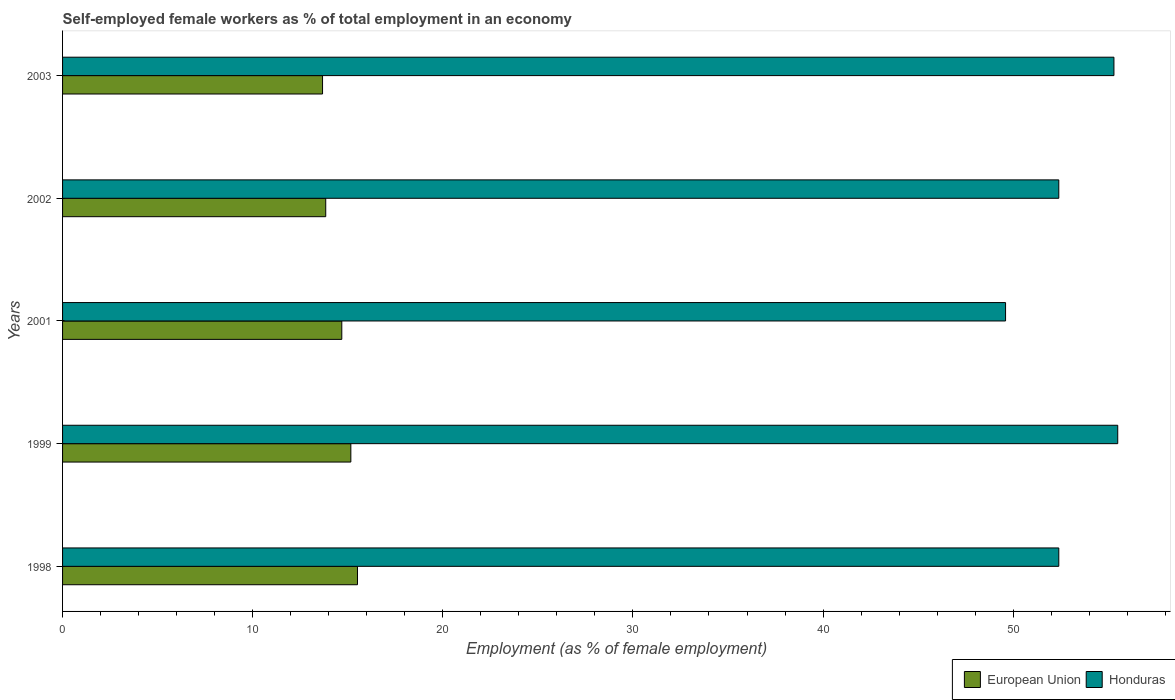Are the number of bars per tick equal to the number of legend labels?
Provide a succinct answer. Yes. How many bars are there on the 5th tick from the top?
Provide a succinct answer. 2. How many bars are there on the 5th tick from the bottom?
Your answer should be very brief. 2. In how many cases, is the number of bars for a given year not equal to the number of legend labels?
Your answer should be compact. 0. What is the percentage of self-employed female workers in Honduras in 2002?
Keep it short and to the point. 52.4. Across all years, what is the maximum percentage of self-employed female workers in Honduras?
Offer a very short reply. 55.5. Across all years, what is the minimum percentage of self-employed female workers in Honduras?
Ensure brevity in your answer.  49.6. What is the total percentage of self-employed female workers in Honduras in the graph?
Your answer should be very brief. 265.2. What is the difference between the percentage of self-employed female workers in European Union in 1998 and that in 1999?
Offer a terse response. 0.35. What is the difference between the percentage of self-employed female workers in European Union in 2001 and the percentage of self-employed female workers in Honduras in 2003?
Give a very brief answer. -40.61. What is the average percentage of self-employed female workers in European Union per year?
Offer a terse response. 14.58. In the year 2002, what is the difference between the percentage of self-employed female workers in European Union and percentage of self-employed female workers in Honduras?
Offer a very short reply. -38.56. What is the ratio of the percentage of self-employed female workers in Honduras in 2002 to that in 2003?
Give a very brief answer. 0.95. Is the difference between the percentage of self-employed female workers in European Union in 1998 and 2003 greater than the difference between the percentage of self-employed female workers in Honduras in 1998 and 2003?
Keep it short and to the point. Yes. What is the difference between the highest and the second highest percentage of self-employed female workers in Honduras?
Provide a short and direct response. 0.2. What is the difference between the highest and the lowest percentage of self-employed female workers in European Union?
Offer a terse response. 1.84. Is the sum of the percentage of self-employed female workers in European Union in 2001 and 2002 greater than the maximum percentage of self-employed female workers in Honduras across all years?
Your response must be concise. No. How many bars are there?
Your answer should be compact. 10. Are all the bars in the graph horizontal?
Ensure brevity in your answer.  Yes. How many years are there in the graph?
Your response must be concise. 5. What is the difference between two consecutive major ticks on the X-axis?
Your answer should be very brief. 10. Are the values on the major ticks of X-axis written in scientific E-notation?
Give a very brief answer. No. Does the graph contain any zero values?
Provide a short and direct response. No. Does the graph contain grids?
Make the answer very short. No. Where does the legend appear in the graph?
Provide a succinct answer. Bottom right. How many legend labels are there?
Provide a succinct answer. 2. What is the title of the graph?
Your answer should be very brief. Self-employed female workers as % of total employment in an economy. Does "Macedonia" appear as one of the legend labels in the graph?
Your response must be concise. No. What is the label or title of the X-axis?
Your response must be concise. Employment (as % of female employment). What is the Employment (as % of female employment) of European Union in 1998?
Provide a succinct answer. 15.51. What is the Employment (as % of female employment) of Honduras in 1998?
Your answer should be compact. 52.4. What is the Employment (as % of female employment) of European Union in 1999?
Provide a short and direct response. 15.16. What is the Employment (as % of female employment) of Honduras in 1999?
Offer a terse response. 55.5. What is the Employment (as % of female employment) in European Union in 2001?
Keep it short and to the point. 14.69. What is the Employment (as % of female employment) in Honduras in 2001?
Keep it short and to the point. 49.6. What is the Employment (as % of female employment) in European Union in 2002?
Make the answer very short. 13.84. What is the Employment (as % of female employment) in Honduras in 2002?
Give a very brief answer. 52.4. What is the Employment (as % of female employment) in European Union in 2003?
Offer a terse response. 13.67. What is the Employment (as % of female employment) in Honduras in 2003?
Give a very brief answer. 55.3. Across all years, what is the maximum Employment (as % of female employment) in European Union?
Make the answer very short. 15.51. Across all years, what is the maximum Employment (as % of female employment) in Honduras?
Offer a very short reply. 55.5. Across all years, what is the minimum Employment (as % of female employment) in European Union?
Keep it short and to the point. 13.67. Across all years, what is the minimum Employment (as % of female employment) of Honduras?
Your response must be concise. 49.6. What is the total Employment (as % of female employment) of European Union in the graph?
Provide a short and direct response. 72.88. What is the total Employment (as % of female employment) of Honduras in the graph?
Offer a very short reply. 265.2. What is the difference between the Employment (as % of female employment) of European Union in 1998 and that in 1999?
Offer a very short reply. 0.35. What is the difference between the Employment (as % of female employment) of European Union in 1998 and that in 2001?
Provide a succinct answer. 0.83. What is the difference between the Employment (as % of female employment) in European Union in 1998 and that in 2002?
Provide a short and direct response. 1.67. What is the difference between the Employment (as % of female employment) in Honduras in 1998 and that in 2002?
Ensure brevity in your answer.  0. What is the difference between the Employment (as % of female employment) of European Union in 1998 and that in 2003?
Your answer should be very brief. 1.84. What is the difference between the Employment (as % of female employment) in European Union in 1999 and that in 2001?
Your answer should be compact. 0.48. What is the difference between the Employment (as % of female employment) in Honduras in 1999 and that in 2001?
Make the answer very short. 5.9. What is the difference between the Employment (as % of female employment) of European Union in 1999 and that in 2002?
Provide a succinct answer. 1.32. What is the difference between the Employment (as % of female employment) in Honduras in 1999 and that in 2002?
Ensure brevity in your answer.  3.1. What is the difference between the Employment (as % of female employment) in European Union in 1999 and that in 2003?
Offer a terse response. 1.49. What is the difference between the Employment (as % of female employment) in European Union in 2001 and that in 2002?
Offer a terse response. 0.84. What is the difference between the Employment (as % of female employment) of Honduras in 2001 and that in 2002?
Ensure brevity in your answer.  -2.8. What is the difference between the Employment (as % of female employment) in European Union in 2001 and that in 2003?
Your answer should be compact. 1.01. What is the difference between the Employment (as % of female employment) of European Union in 2002 and that in 2003?
Offer a very short reply. 0.17. What is the difference between the Employment (as % of female employment) of European Union in 1998 and the Employment (as % of female employment) of Honduras in 1999?
Offer a very short reply. -39.99. What is the difference between the Employment (as % of female employment) in European Union in 1998 and the Employment (as % of female employment) in Honduras in 2001?
Offer a very short reply. -34.09. What is the difference between the Employment (as % of female employment) of European Union in 1998 and the Employment (as % of female employment) of Honduras in 2002?
Ensure brevity in your answer.  -36.89. What is the difference between the Employment (as % of female employment) in European Union in 1998 and the Employment (as % of female employment) in Honduras in 2003?
Give a very brief answer. -39.79. What is the difference between the Employment (as % of female employment) of European Union in 1999 and the Employment (as % of female employment) of Honduras in 2001?
Offer a very short reply. -34.44. What is the difference between the Employment (as % of female employment) of European Union in 1999 and the Employment (as % of female employment) of Honduras in 2002?
Your answer should be very brief. -37.24. What is the difference between the Employment (as % of female employment) in European Union in 1999 and the Employment (as % of female employment) in Honduras in 2003?
Ensure brevity in your answer.  -40.14. What is the difference between the Employment (as % of female employment) of European Union in 2001 and the Employment (as % of female employment) of Honduras in 2002?
Your response must be concise. -37.71. What is the difference between the Employment (as % of female employment) in European Union in 2001 and the Employment (as % of female employment) in Honduras in 2003?
Provide a short and direct response. -40.61. What is the difference between the Employment (as % of female employment) in European Union in 2002 and the Employment (as % of female employment) in Honduras in 2003?
Your answer should be compact. -41.46. What is the average Employment (as % of female employment) in European Union per year?
Your response must be concise. 14.58. What is the average Employment (as % of female employment) of Honduras per year?
Ensure brevity in your answer.  53.04. In the year 1998, what is the difference between the Employment (as % of female employment) in European Union and Employment (as % of female employment) in Honduras?
Give a very brief answer. -36.89. In the year 1999, what is the difference between the Employment (as % of female employment) of European Union and Employment (as % of female employment) of Honduras?
Offer a very short reply. -40.34. In the year 2001, what is the difference between the Employment (as % of female employment) of European Union and Employment (as % of female employment) of Honduras?
Make the answer very short. -34.91. In the year 2002, what is the difference between the Employment (as % of female employment) of European Union and Employment (as % of female employment) of Honduras?
Give a very brief answer. -38.56. In the year 2003, what is the difference between the Employment (as % of female employment) in European Union and Employment (as % of female employment) in Honduras?
Your answer should be very brief. -41.63. What is the ratio of the Employment (as % of female employment) of European Union in 1998 to that in 1999?
Ensure brevity in your answer.  1.02. What is the ratio of the Employment (as % of female employment) of Honduras in 1998 to that in 1999?
Offer a very short reply. 0.94. What is the ratio of the Employment (as % of female employment) in European Union in 1998 to that in 2001?
Your answer should be compact. 1.06. What is the ratio of the Employment (as % of female employment) of Honduras in 1998 to that in 2001?
Ensure brevity in your answer.  1.06. What is the ratio of the Employment (as % of female employment) of European Union in 1998 to that in 2002?
Your answer should be very brief. 1.12. What is the ratio of the Employment (as % of female employment) of European Union in 1998 to that in 2003?
Offer a very short reply. 1.13. What is the ratio of the Employment (as % of female employment) in Honduras in 1998 to that in 2003?
Ensure brevity in your answer.  0.95. What is the ratio of the Employment (as % of female employment) in European Union in 1999 to that in 2001?
Your answer should be very brief. 1.03. What is the ratio of the Employment (as % of female employment) of Honduras in 1999 to that in 2001?
Your response must be concise. 1.12. What is the ratio of the Employment (as % of female employment) in European Union in 1999 to that in 2002?
Offer a very short reply. 1.1. What is the ratio of the Employment (as % of female employment) in Honduras in 1999 to that in 2002?
Your response must be concise. 1.06. What is the ratio of the Employment (as % of female employment) of European Union in 1999 to that in 2003?
Keep it short and to the point. 1.11. What is the ratio of the Employment (as % of female employment) of Honduras in 1999 to that in 2003?
Offer a very short reply. 1. What is the ratio of the Employment (as % of female employment) of European Union in 2001 to that in 2002?
Make the answer very short. 1.06. What is the ratio of the Employment (as % of female employment) of Honduras in 2001 to that in 2002?
Make the answer very short. 0.95. What is the ratio of the Employment (as % of female employment) of European Union in 2001 to that in 2003?
Provide a succinct answer. 1.07. What is the ratio of the Employment (as % of female employment) in Honduras in 2001 to that in 2003?
Give a very brief answer. 0.9. What is the ratio of the Employment (as % of female employment) in European Union in 2002 to that in 2003?
Make the answer very short. 1.01. What is the ratio of the Employment (as % of female employment) in Honduras in 2002 to that in 2003?
Your response must be concise. 0.95. What is the difference between the highest and the second highest Employment (as % of female employment) of European Union?
Your answer should be very brief. 0.35. What is the difference between the highest and the second highest Employment (as % of female employment) in Honduras?
Your answer should be very brief. 0.2. What is the difference between the highest and the lowest Employment (as % of female employment) of European Union?
Provide a succinct answer. 1.84. 